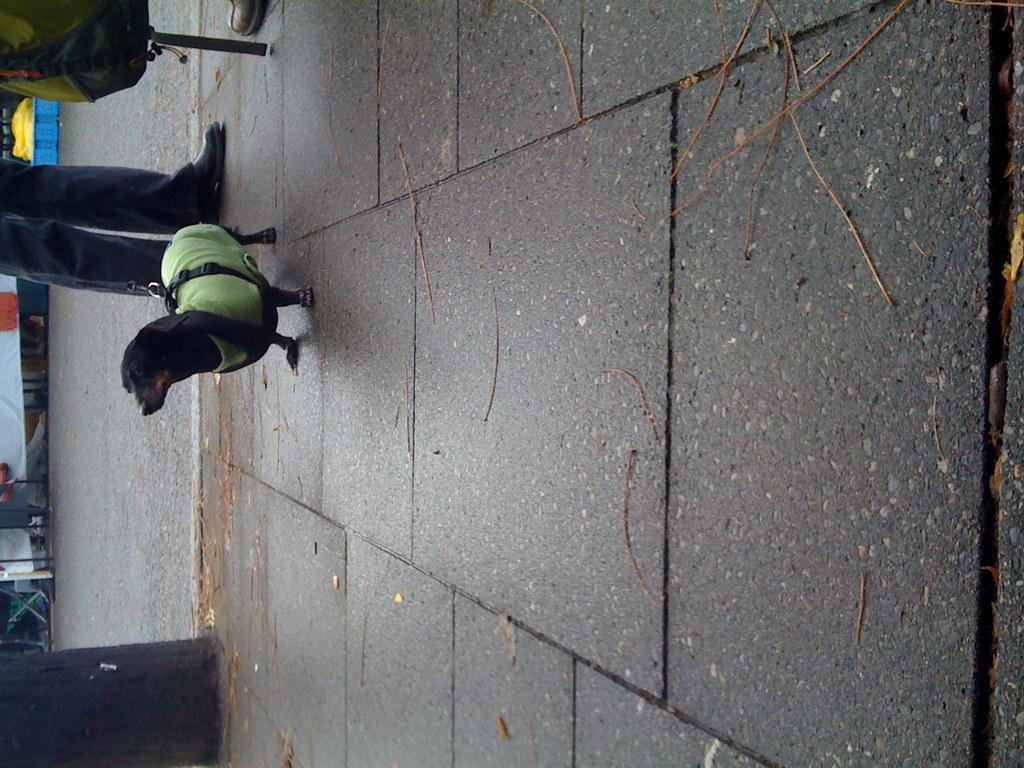Could you give a brief overview of what you see in this image? In this image we can see a dog, legs of a person, a black color object on the pavement and a backpack, there is a road beside the pavement. 